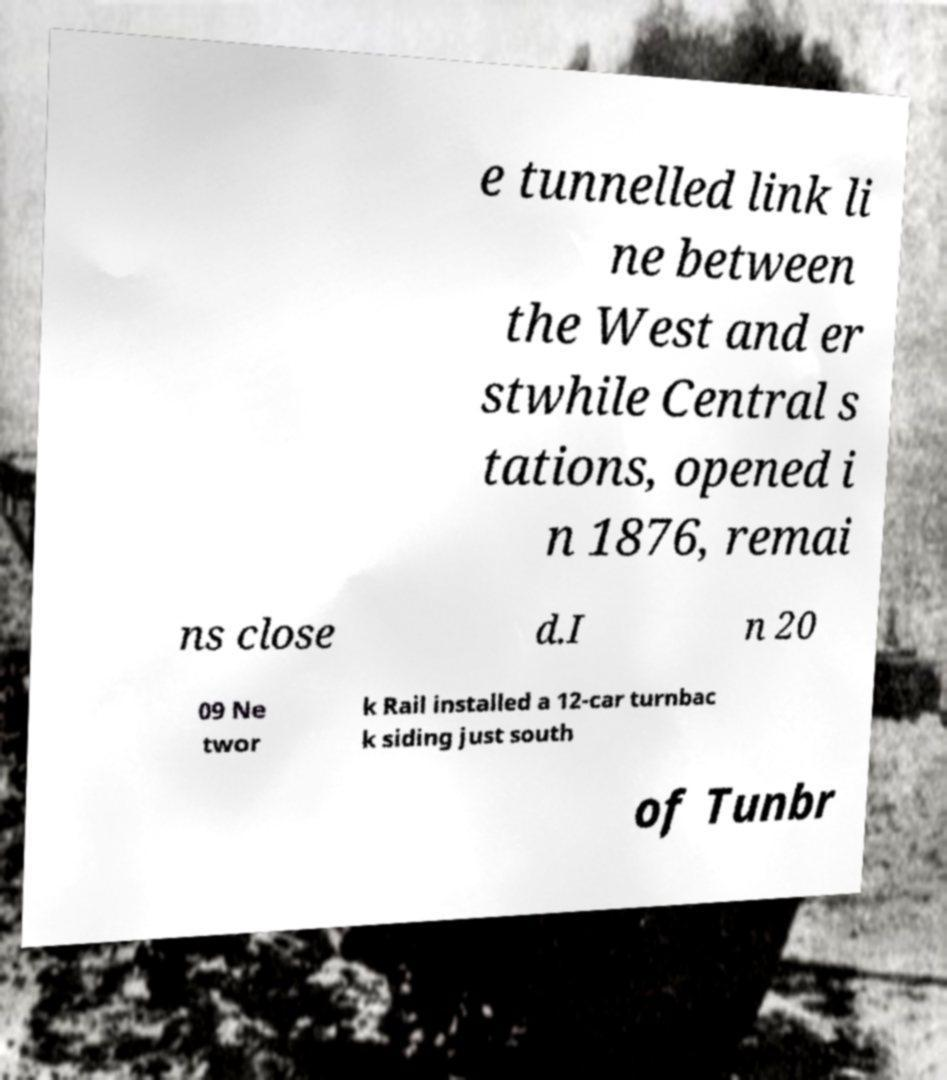Can you accurately transcribe the text from the provided image for me? e tunnelled link li ne between the West and er stwhile Central s tations, opened i n 1876, remai ns close d.I n 20 09 Ne twor k Rail installed a 12-car turnbac k siding just south of Tunbr 